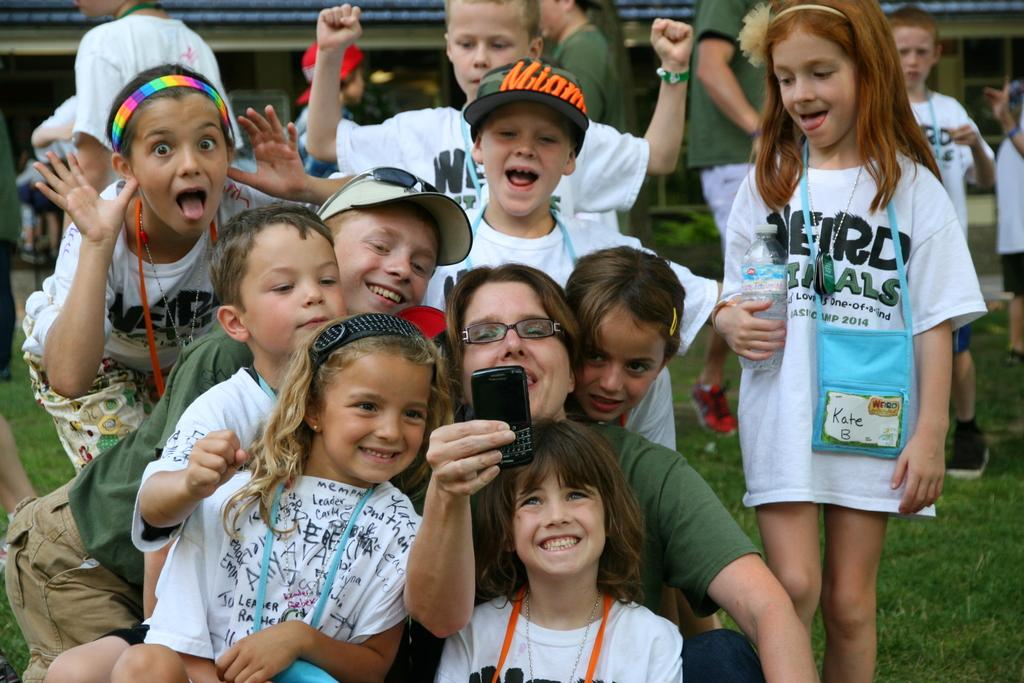What are the people in the image doing? The people in the image are on the ground. Can you describe any objects or devices that the people are holding? Yes, a person is holding a cellphone. What can be seen in the background of the image? There is a building in the background of the image. What type of cracker is being kicked in the image? There is no cracker present in the image. 